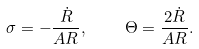Convert formula to latex. <formula><loc_0><loc_0><loc_500><loc_500>\sigma = - \frac { \dot { R } } { A R } , \quad \Theta = \frac { 2 \dot { R } } { A R } .</formula> 